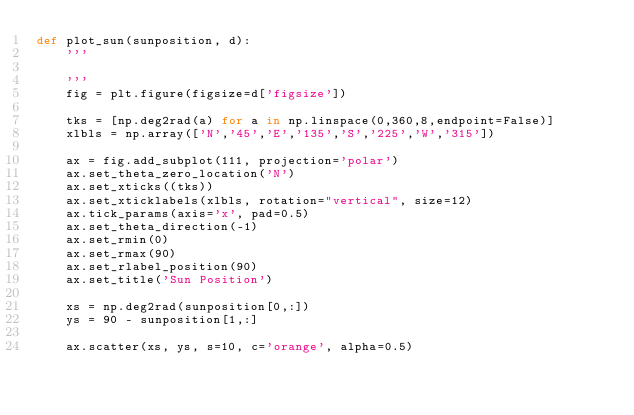<code> <loc_0><loc_0><loc_500><loc_500><_Python_>def plot_sun(sunposition, d):
    '''

    '''
    fig = plt.figure(figsize=d['figsize'])

    tks = [np.deg2rad(a) for a in np.linspace(0,360,8,endpoint=False)]
    xlbls = np.array(['N','45','E','135','S','225','W','315'])

    ax = fig.add_subplot(111, projection='polar')
    ax.set_theta_zero_location('N')
    ax.set_xticks((tks))
    ax.set_xticklabels(xlbls, rotation="vertical", size=12)
    ax.tick_params(axis='x', pad=0.5)
    ax.set_theta_direction(-1)
    ax.set_rmin(0)
    ax.set_rmax(90)
    ax.set_rlabel_position(90)
    ax.set_title('Sun Position')

    xs = np.deg2rad(sunposition[0,:])
    ys = 90 - sunposition[1,:]

    ax.scatter(xs, ys, s=10, c='orange', alpha=0.5)
    </code> 